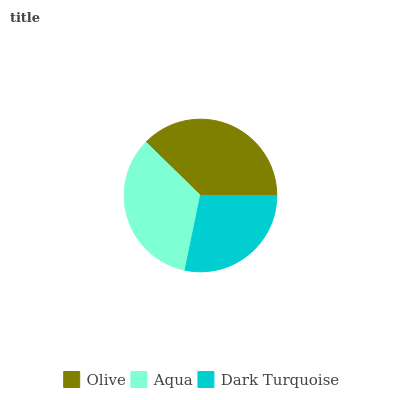Is Dark Turquoise the minimum?
Answer yes or no. Yes. Is Olive the maximum?
Answer yes or no. Yes. Is Aqua the minimum?
Answer yes or no. No. Is Aqua the maximum?
Answer yes or no. No. Is Olive greater than Aqua?
Answer yes or no. Yes. Is Aqua less than Olive?
Answer yes or no. Yes. Is Aqua greater than Olive?
Answer yes or no. No. Is Olive less than Aqua?
Answer yes or no. No. Is Aqua the high median?
Answer yes or no. Yes. Is Aqua the low median?
Answer yes or no. Yes. Is Olive the high median?
Answer yes or no. No. Is Dark Turquoise the low median?
Answer yes or no. No. 